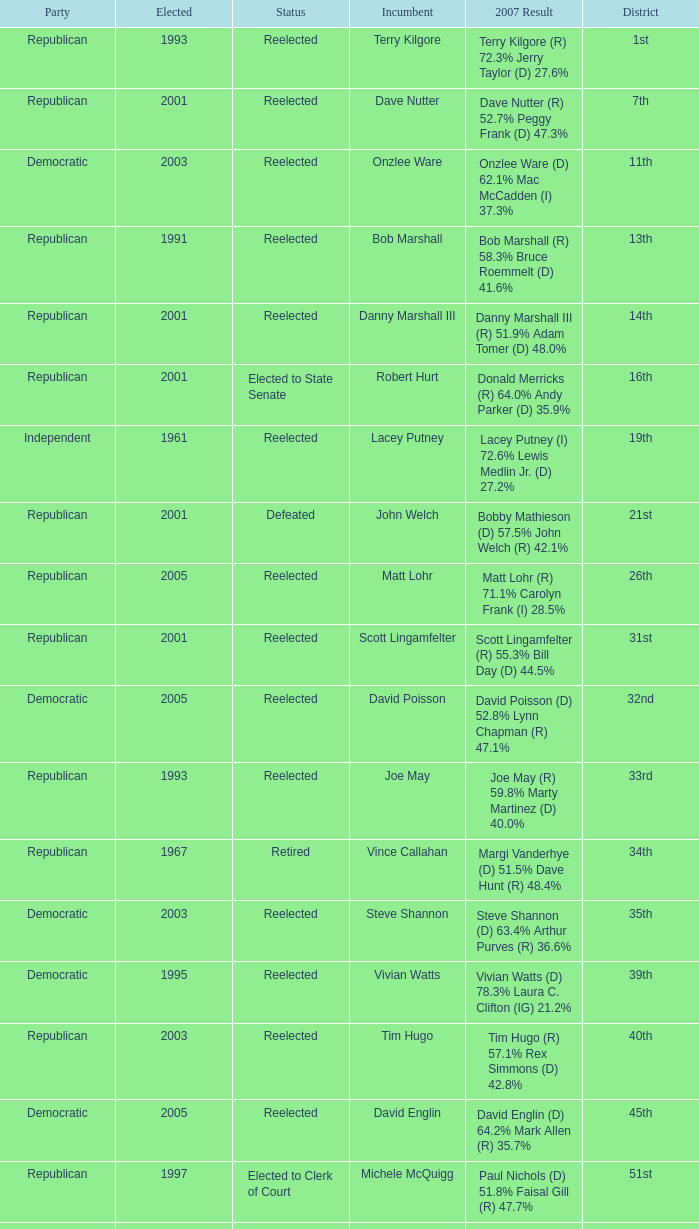How many times was incumbent onzlee ware elected? 1.0. 